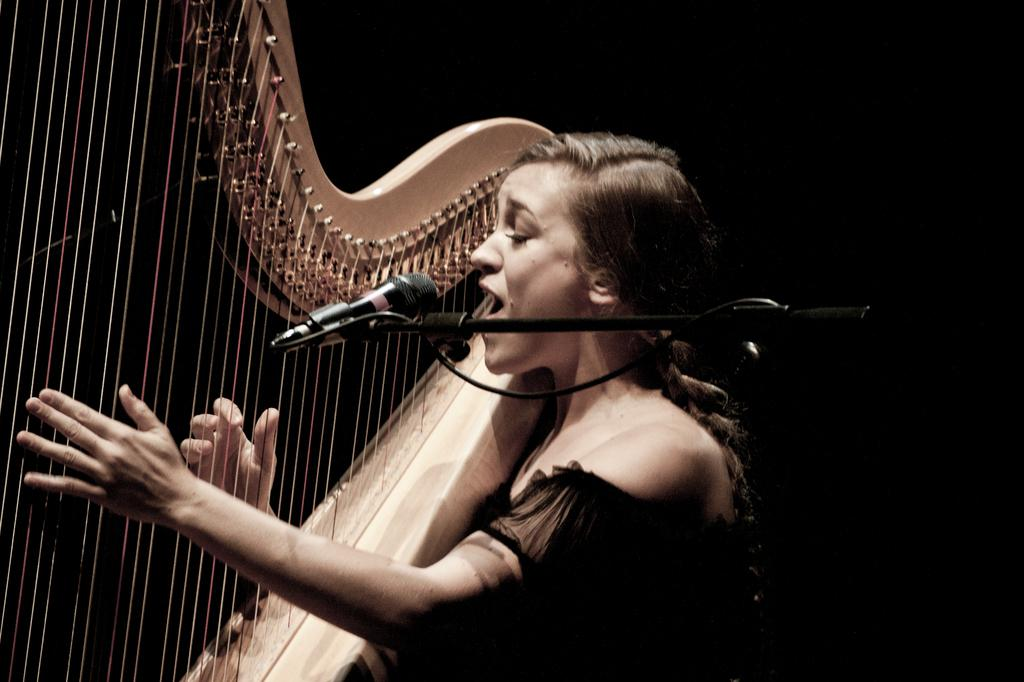Who is the main subject in the image? There is a woman in the image. What is the woman doing in the image? The woman is singing and playing a musical instrument. What object is present in the image that is commonly used for amplifying sound? There is a microphone (mic) in the image. Can you tell me how many times the woman laughs while playing the musical instrument in the image? There is no indication in the image that the woman is laughing while playing the musical instrument. 